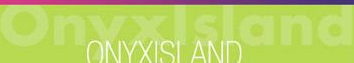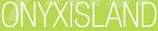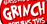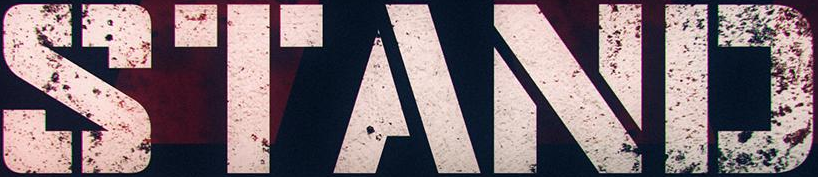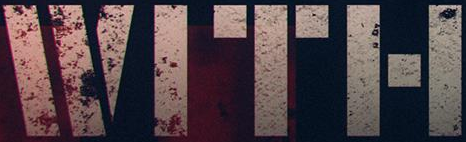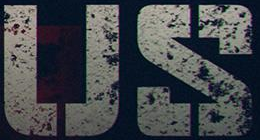Read the text from these images in sequence, separated by a semicolon. Onyxlsland; ONYXISLAND; GRINGH; STAND; WITH; US 